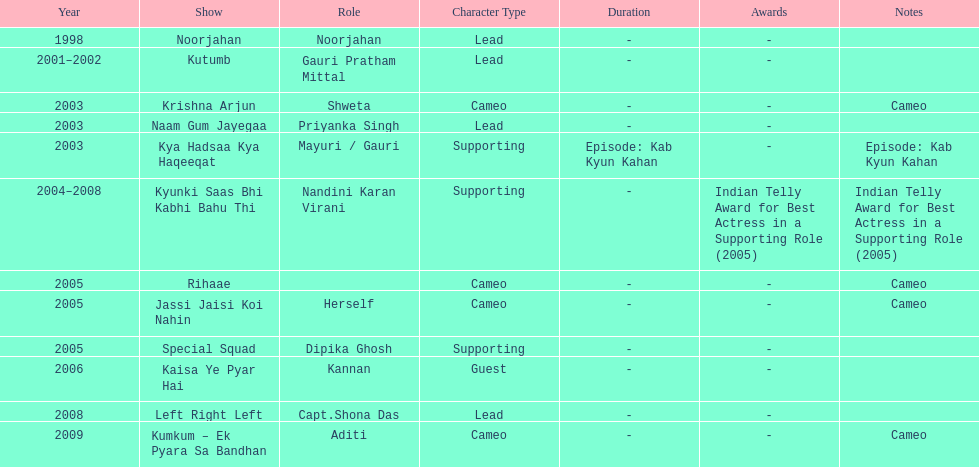The show above left right left Kaisa Ye Pyar Hai. 